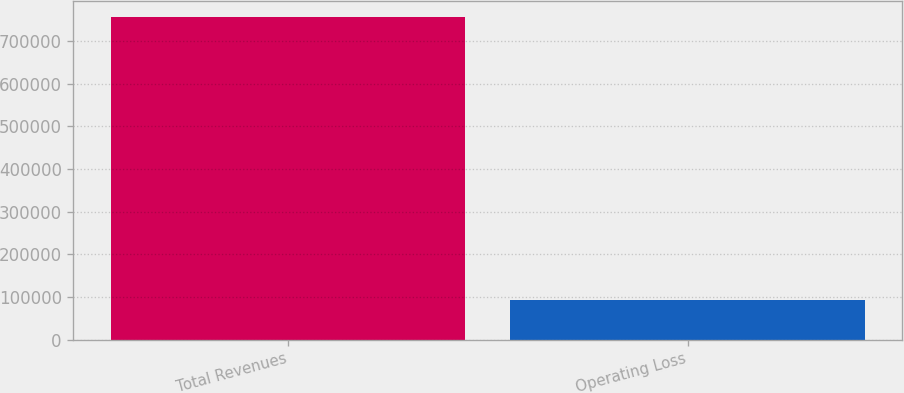Convert chart to OTSL. <chart><loc_0><loc_0><loc_500><loc_500><bar_chart><fcel>Total Revenues<fcel>Operating Loss<nl><fcel>755542<fcel>93623<nl></chart> 